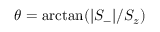<formula> <loc_0><loc_0><loc_500><loc_500>\theta = \arctan ( | S _ { - } | / S _ { z } )</formula> 